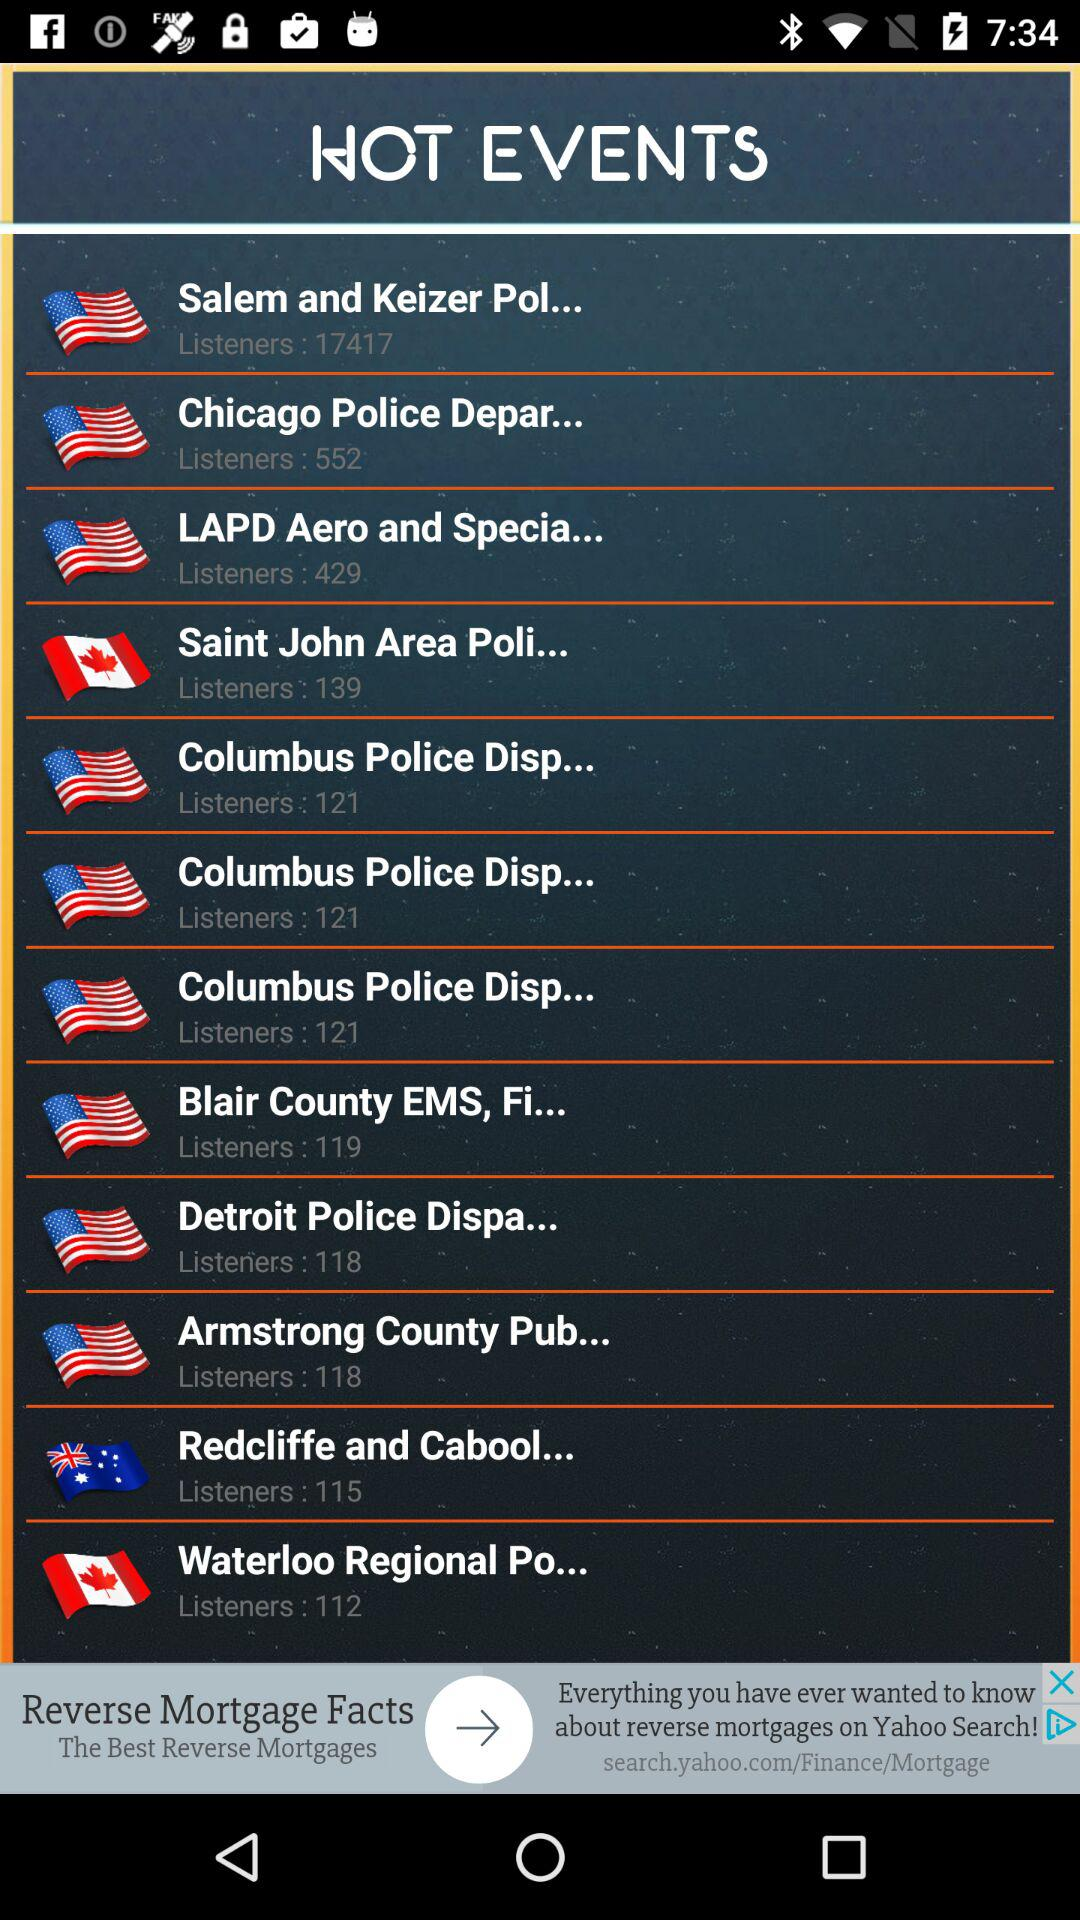Which events have 115 listeners? There are 115 listeners in the "Redcliffe and Cabool..." event. 